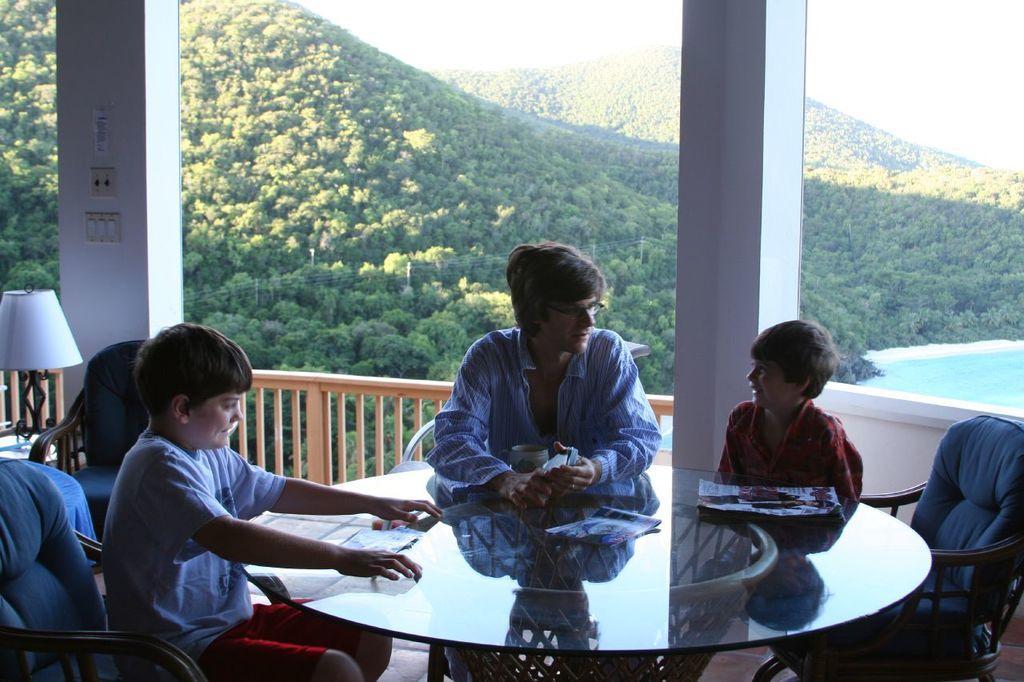Could you give a brief overview of what you see in this image? These two children and a person are sitting on the chairs around a table. Behind them there are trees and water. 